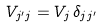<formula> <loc_0><loc_0><loc_500><loc_500>V _ { j ^ { \prime } j } = V _ { j } \, \delta _ { j j ^ { \prime } }</formula> 